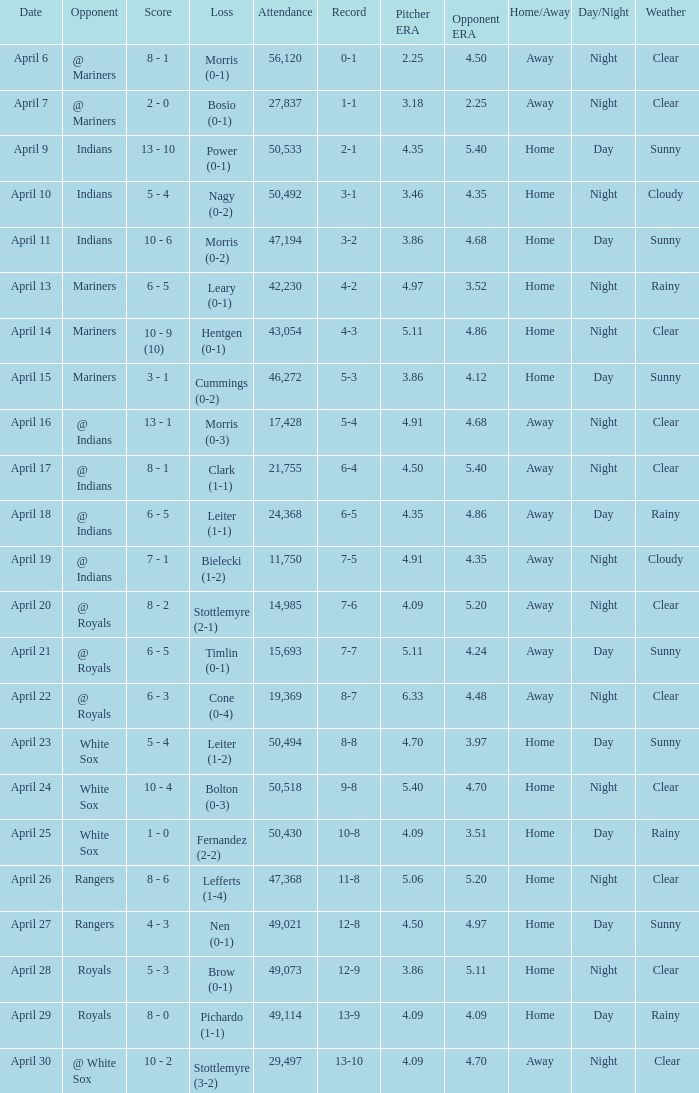What scored is recorded on April 24? 10 - 4. 